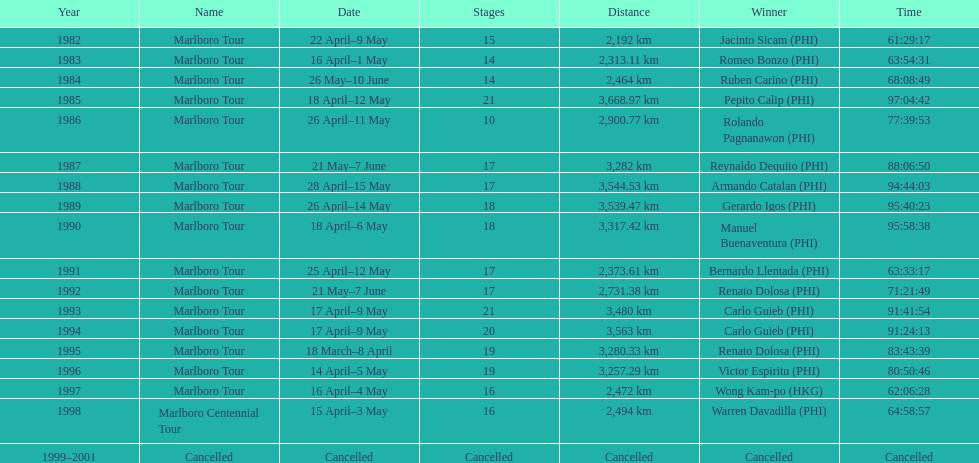How many parts were in the 1982 marlboro tour? 15. 